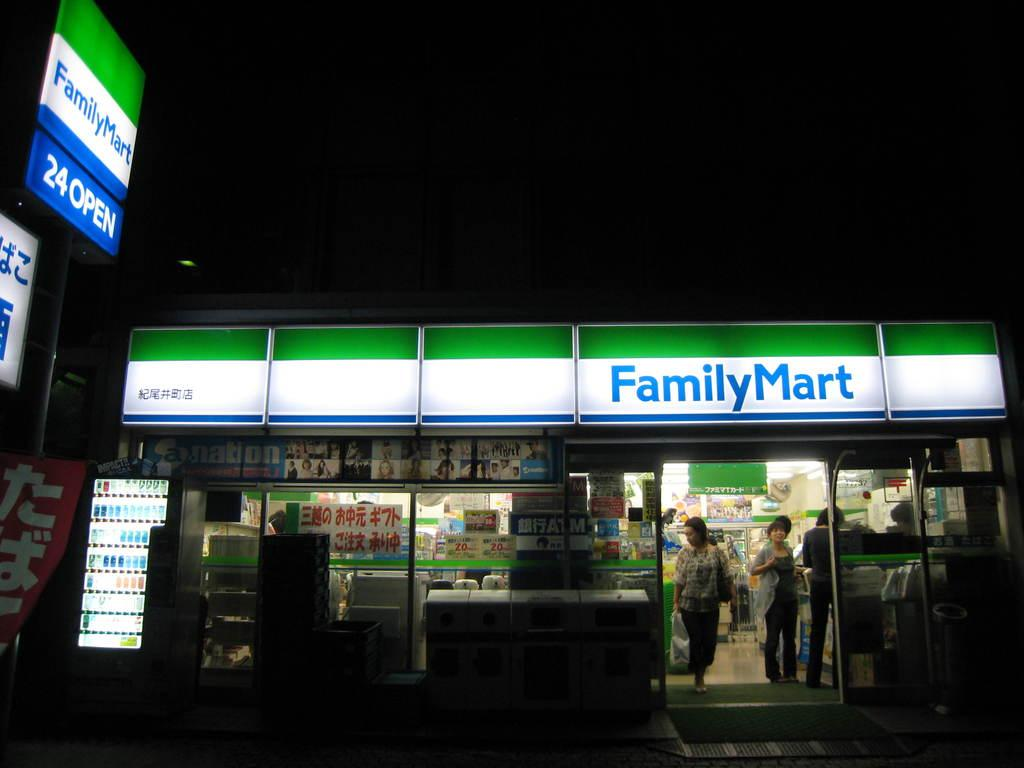Provide a one-sentence caption for the provided image. A Family Mart that is lit up in the night. 